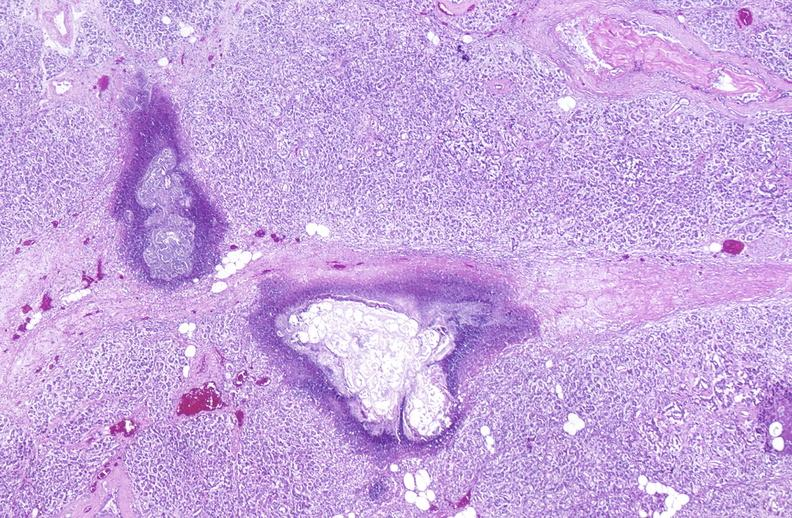does this image show pancreatic fat necrosis?
Answer the question using a single word or phrase. Yes 